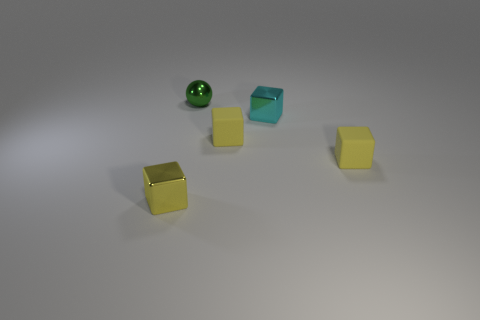Are there fewer small spheres on the left side of the cyan metallic cube than big purple balls?
Your answer should be very brief. No. Is the shape of the yellow metallic object the same as the shiny thing right of the green ball?
Keep it short and to the point. Yes. Is there a large yellow ball made of the same material as the tiny cyan cube?
Offer a very short reply. No. Is there a small yellow thing to the left of the tiny rubber cube behind the rubber thing that is on the right side of the cyan cube?
Give a very brief answer. Yes. How many other objects are the same shape as the yellow shiny object?
Your answer should be very brief. 3. What color is the object that is to the left of the small object behind the metallic object right of the green ball?
Your answer should be very brief. Yellow. What number of small cyan metal cubes are there?
Make the answer very short. 1. What number of big objects are either yellow cubes or matte objects?
Your response must be concise. 0. What is the shape of the yellow shiny thing that is the same size as the green sphere?
Your answer should be compact. Cube. What material is the small yellow cube that is behind the tiny yellow cube on the right side of the cyan shiny block?
Your answer should be compact. Rubber. 